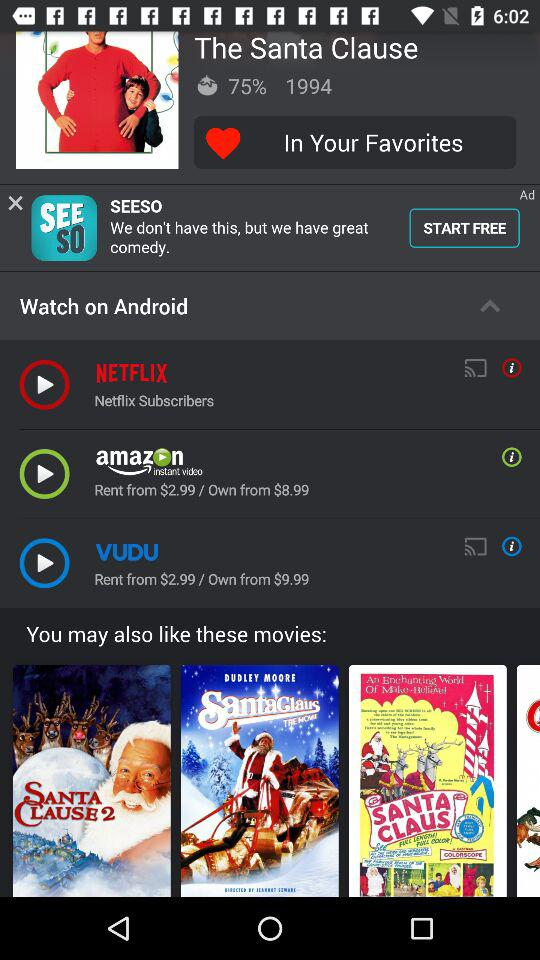How many providers offer this movie?
Answer the question using a single word or phrase. 3 